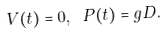Convert formula to latex. <formula><loc_0><loc_0><loc_500><loc_500>V ( t ) = 0 , \text { } P ( t ) = g D .</formula> 